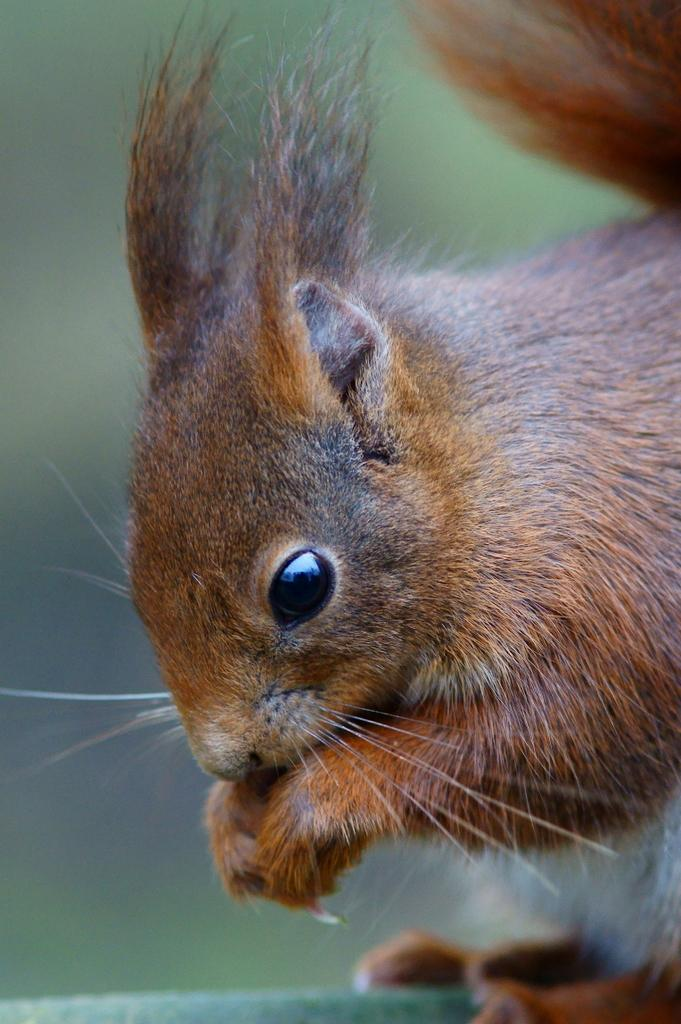What type of animal is in the image? There is a squirrel in the image. Can you describe the coloring of the squirrel? The squirrel has brown and black coloring. What can be observed about the background of the image? The background of the image is blurred. What type of wealth does the squirrel possess in the image? There is no indication of wealth in the image, as it features a squirrel with brown and black coloring against a blurred background. 